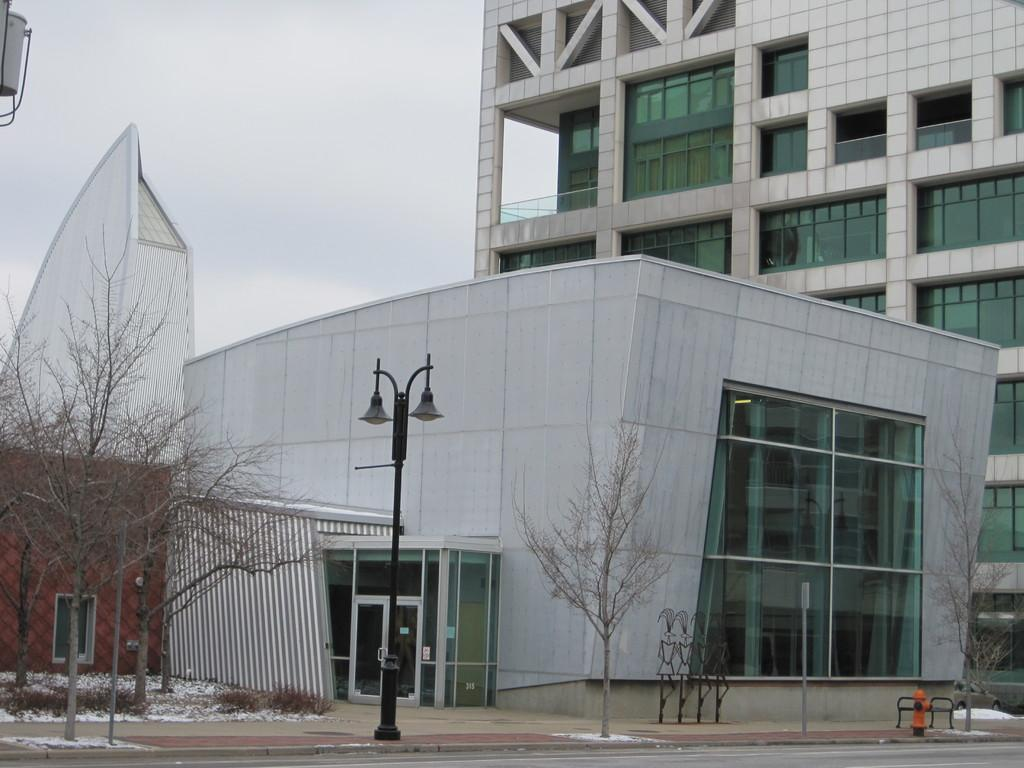What type of pathway is visible in the image? There is a road in the image. What object is present for fire safety purposes? There is a hydrant in the image. What mode of transportation can be seen in the image? There is a car in the image. What type of vegetation is present in the image? There are trees in the image. What structures are present in the image that support electrical wires or other utilities? There are poles in the image. What type of buildings are visible in the image? There are buildings with windows in the image. What can be seen in the background of the image? The sky with clouds is visible in the background of the image. What type of beam is holding up the buildings in the image? There is no specific beam mentioned in the image, but the buildings are supported by their own structures. Is there any magic happening in the image? There is no indication of magic in the image; it depicts a realistic scene. What is the chance of rain in the image? The image does not provide any information about the weather or the chance of rain. 